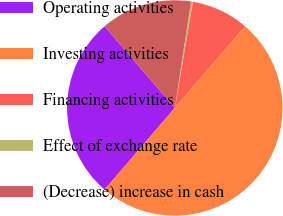Convert chart to OTSL. <chart><loc_0><loc_0><loc_500><loc_500><pie_chart><fcel>Operating activities<fcel>Investing activities<fcel>Financing activities<fcel>Effect of exchange rate<fcel>(Decrease) increase in cash<nl><fcel>27.39%<fcel>50.0%<fcel>8.62%<fcel>0.28%<fcel>13.71%<nl></chart> 